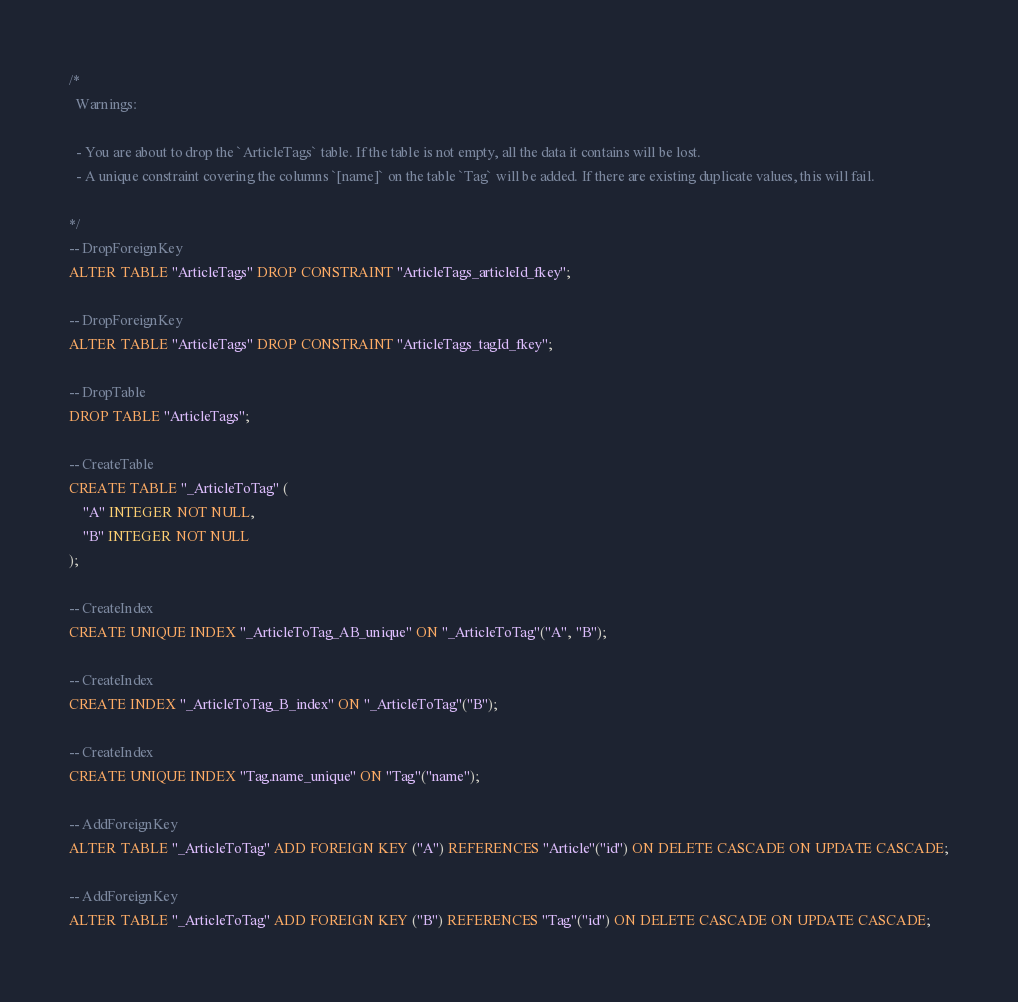Convert code to text. <code><loc_0><loc_0><loc_500><loc_500><_SQL_>/*
  Warnings:

  - You are about to drop the `ArticleTags` table. If the table is not empty, all the data it contains will be lost.
  - A unique constraint covering the columns `[name]` on the table `Tag` will be added. If there are existing duplicate values, this will fail.

*/
-- DropForeignKey
ALTER TABLE "ArticleTags" DROP CONSTRAINT "ArticleTags_articleId_fkey";

-- DropForeignKey
ALTER TABLE "ArticleTags" DROP CONSTRAINT "ArticleTags_tagId_fkey";

-- DropTable
DROP TABLE "ArticleTags";

-- CreateTable
CREATE TABLE "_ArticleToTag" (
    "A" INTEGER NOT NULL,
    "B" INTEGER NOT NULL
);

-- CreateIndex
CREATE UNIQUE INDEX "_ArticleToTag_AB_unique" ON "_ArticleToTag"("A", "B");

-- CreateIndex
CREATE INDEX "_ArticleToTag_B_index" ON "_ArticleToTag"("B");

-- CreateIndex
CREATE UNIQUE INDEX "Tag.name_unique" ON "Tag"("name");

-- AddForeignKey
ALTER TABLE "_ArticleToTag" ADD FOREIGN KEY ("A") REFERENCES "Article"("id") ON DELETE CASCADE ON UPDATE CASCADE;

-- AddForeignKey
ALTER TABLE "_ArticleToTag" ADD FOREIGN KEY ("B") REFERENCES "Tag"("id") ON DELETE CASCADE ON UPDATE CASCADE;
</code> 